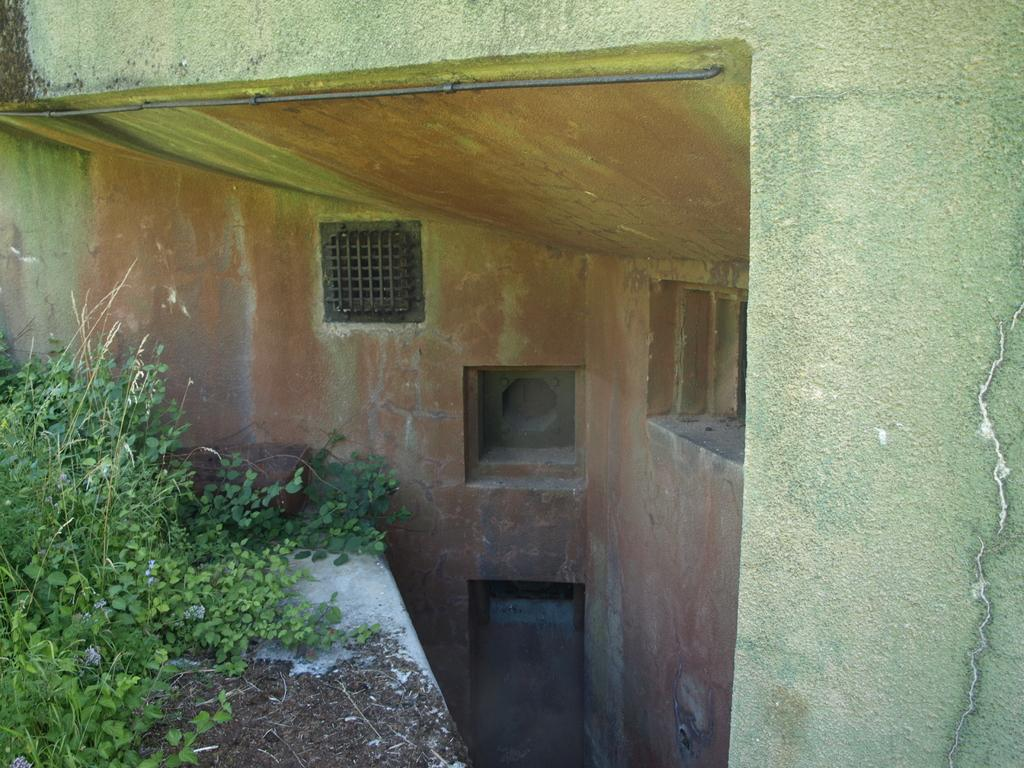What type of scene is depicted in the image? The image is an outside view of a building. What architectural feature can be seen in the image? There is a wall in the image. What object is present in the image that might be used for hanging or supporting something? There is a rod in the image. What feature in the image might be related to air circulation or temperature control? There is ventilation in the image. What type of structure might be used for security or decoration in the image? There are grilles in the image. What type of opening is visible in the image that might allow light or air to enter the building? There is a window in the image. What type of vegetation is present on the left side of the image? There are plants on the left side of the image. What type of pies can be seen cooling on the windowsill in the image? There are no pies present in the image; it is an outside view of a building with plants and architectural features. 